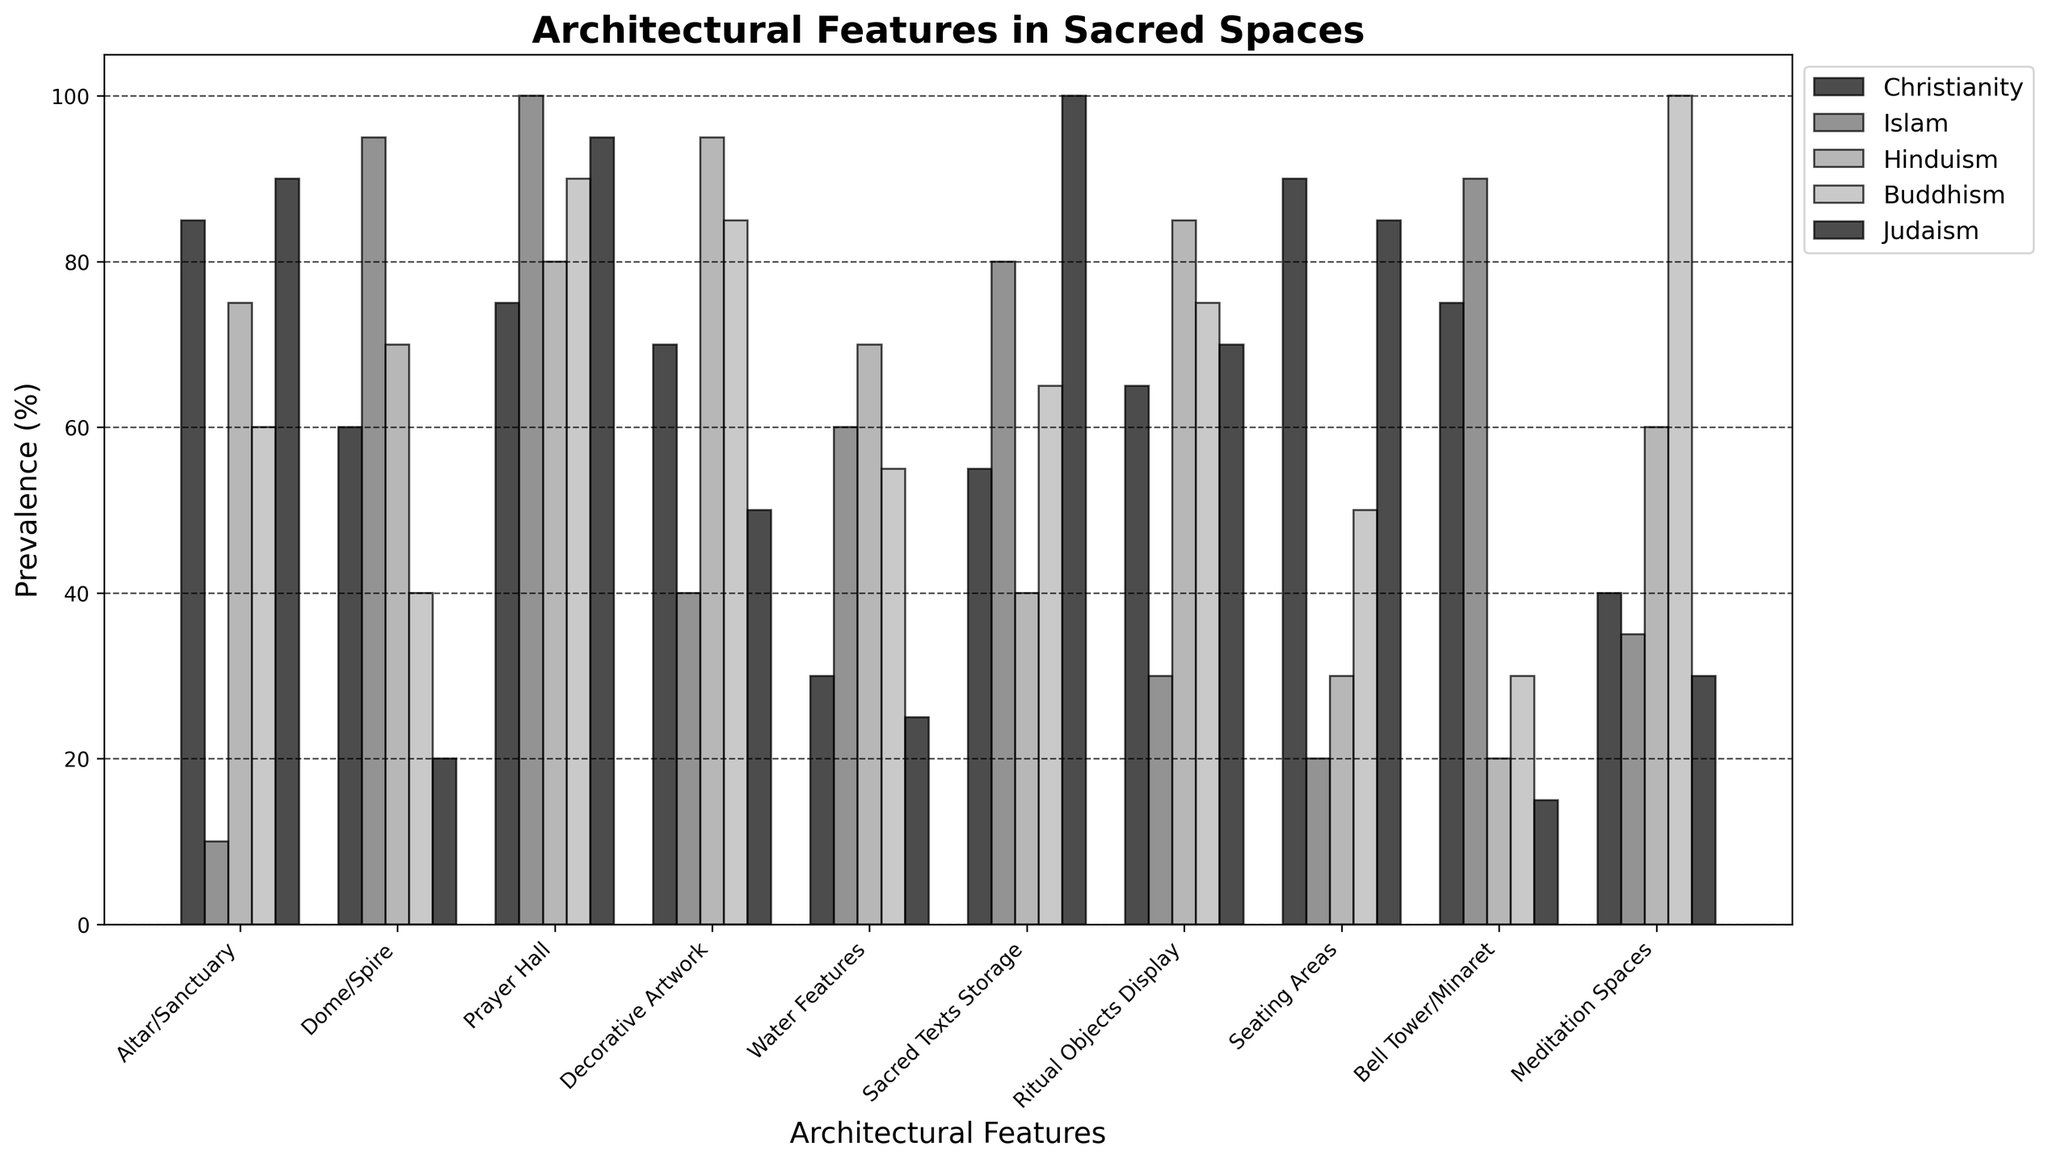What is the title of the bar chart? The title of the bar chart is usually placed at the top. It reads "Architectural Features in Sacred Spaces".
Answer: Architectural Features in Sacred Spaces Which religion shows the highest prevalence of meditation spaces? The highest bar in the "Meditation Spaces" category belongs to Buddhism.
Answer: Buddhism What architectural feature has the highest prevalence in Judaism? We need to find the highest bar for Judaism. It is in the "Sacred Texts Storage" category with a value of 100%.
Answer: Sacred Texts Storage Which architectural feature has the lowest prevalence in Islam? The lowest bar for Islam is in the "Seating Areas" category with a value of 20%.
Answer: Seating Areas How many architectural features have a prevalence of 90% or higher in Christianity? In Christianity, the bars that reach or exceed 90% are "Altar/Sanctuary" (85%), "Prayer Hall" (75%), and "Seating Areas" (90%). Therefore, 2 features reach or exceed 90%.
Answer: 1 What is the average prevalence of decorative artwork across all religions? We add the values for decorative artwork across all religions and divide by the number of religions: (70 + 40 + 95 + 85 + 50) / 5 = 68.
Answer: 68 Is the prevalence of domes/spires higher in Islam or Christianity? By comparing the heights of the bars in the "Dome/Spire" category for Islam (95) and Christianity (60), we see that Islam has a higher prevalence.
Answer: Islam Which religion has the lowest prevalence of bell towers/minarets? Looking at the "Bell Tower/Minaret" category, the lowest bar belongs to Judaism with a value of 15%.
Answer: Judaism How much higher is the prevalence of ritual objects display in Hinduism compared to Christianity? In the "Ritual Objects Display" category, Hinduism has a value of 85% and Christianity has a value of 65%. The difference is 85 - 65 = 20%.
Answer: 20% Which two religions have equal prevalence for water features? In the "Water Features" category, Christianity and Judaism both have a prevalence of 30%.
Answer: Christianity and Judaism 